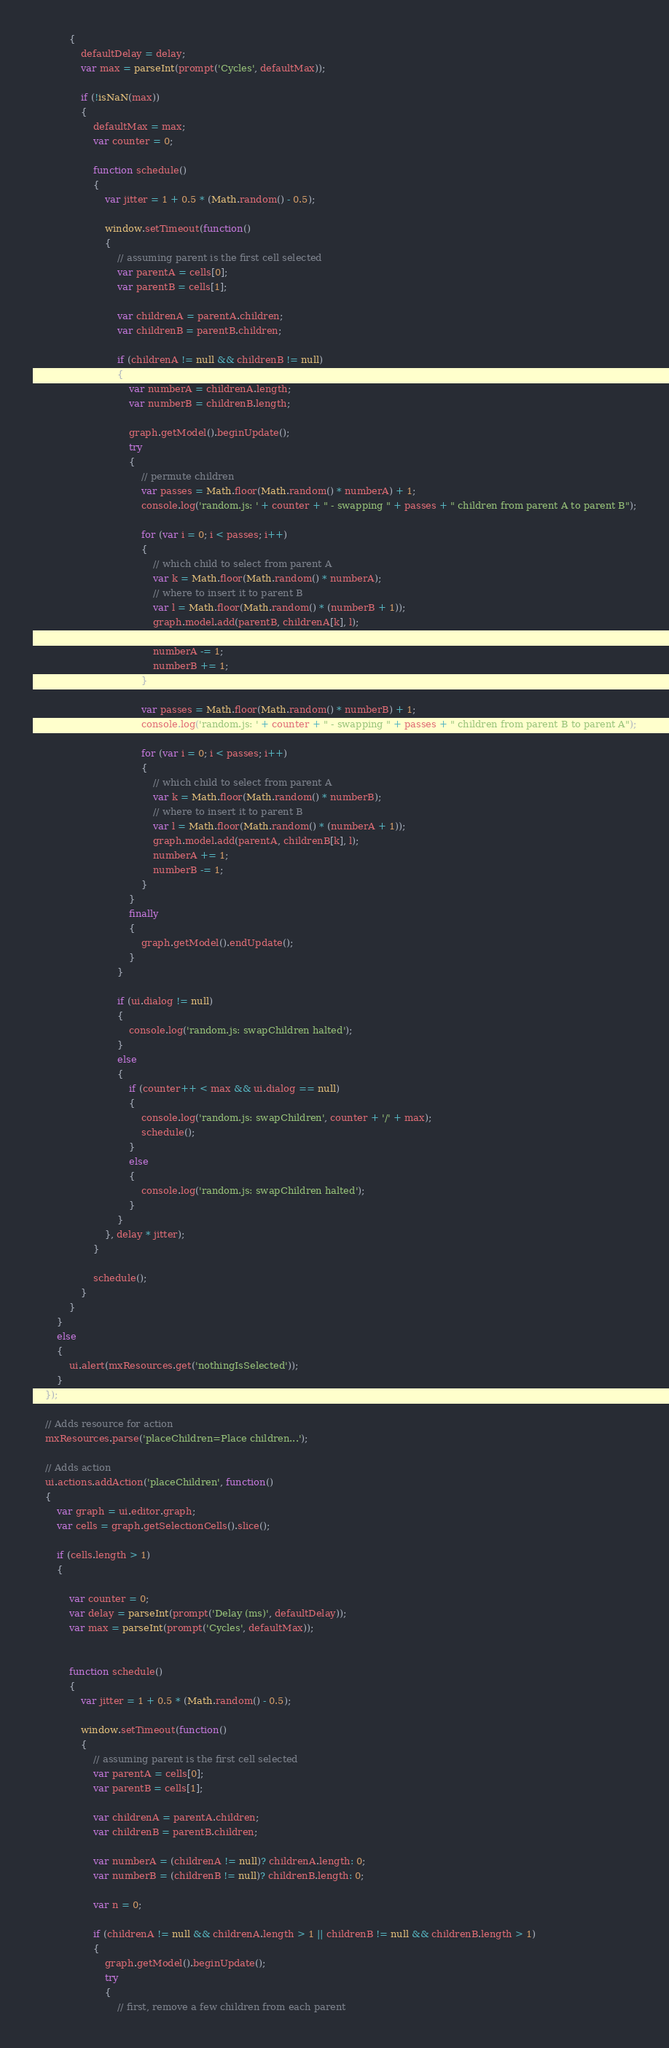<code> <loc_0><loc_0><loc_500><loc_500><_JavaScript_>			{
				defaultDelay = delay;
				var max = parseInt(prompt('Cycles', defaultMax));

				if (!isNaN(max))
				{
					defaultMax = max;
					var counter = 0;
					
					function schedule()
					{
						var jitter = 1 + 0.5 * (Math.random() - 0.5);
						
						window.setTimeout(function()
						{
							// assuming parent is the first cell selected
							var parentA = cells[0];
							var parentB = cells[1];
							
							var childrenA = parentA.children;
							var childrenB = parentB.children;
							
							if (childrenA != null && childrenB != null)
							{
								var numberA = childrenA.length;
								var numberB = childrenB.length;

								graph.getModel().beginUpdate();
								try
								{
									// permute children
									var passes = Math.floor(Math.random() * numberA) + 1;
									console.log('random.js: ' + counter + " - swapping " + passes + " children from parent A to parent B");
									
									for (var i = 0; i < passes; i++)
									{
										// which child to select from parent A
										var k = Math.floor(Math.random() * numberA);
										// where to insert it to parent B
										var l = Math.floor(Math.random() * (numberB + 1));
										graph.model.add(parentB, childrenA[k], l);
										
										numberA -= 1;
										numberB += 1;
									}

									var passes = Math.floor(Math.random() * numberB) + 1;
									console.log('random.js: ' + counter + " - swapping " + passes + " children from parent B to parent A");
									
									for (var i = 0; i < passes; i++)
									{
										// which child to select from parent A
										var k = Math.floor(Math.random() * numberB);
										// where to insert it to parent B
										var l = Math.floor(Math.random() * (numberA + 1));
										graph.model.add(parentA, childrenB[k], l);
										numberA += 1;
										numberB -= 1;
									}
								}
								finally
								{
									graph.getModel().endUpdate();
								}
							}
							
							if (ui.dialog != null)
							{
								console.log('random.js: swapChildren halted');
							}
							else
							{
								if (counter++ < max && ui.dialog == null)
								{
									console.log('random.js: swapChildren', counter + '/' + max);
									schedule();
								}
								else
								{
									console.log('random.js: swapChildren halted');
								}
							}
						}, delay * jitter);
					}
					
					schedule();
				}
			}
		}
		else
		{
			ui.alert(mxResources.get('nothingIsSelected'));
		}
	});
	
	// Adds resource for action
	mxResources.parse('placeChildren=Place children...');

	// Adds action
	ui.actions.addAction('placeChildren', function()
	{
		var graph = ui.editor.graph;
		var cells = graph.getSelectionCells().slice();
		
		if (cells.length > 1)
		{

			var counter = 0;
			var delay = parseInt(prompt('Delay (ms)', defaultDelay));
			var max = parseInt(prompt('Cycles', defaultMax));
			
			
			function schedule()
			{
				var jitter = 1 + 0.5 * (Math.random() - 0.5);
				
				window.setTimeout(function()
				{
					// assuming parent is the first cell selected
					var parentA = cells[0];
					var parentB = cells[1];
					
					var childrenA = parentA.children;
					var childrenB = parentB.children;
					
					var numberA = (childrenA != null)? childrenA.length: 0;
					var numberB = (childrenB != null)? childrenB.length: 0;
					
					var n = 0;
					
					if (childrenA != null && childrenA.length > 1 || childrenB != null && childrenB.length > 1)
					{
						graph.getModel().beginUpdate();
						try
						{
							// first, remove a few children from each parent</code> 